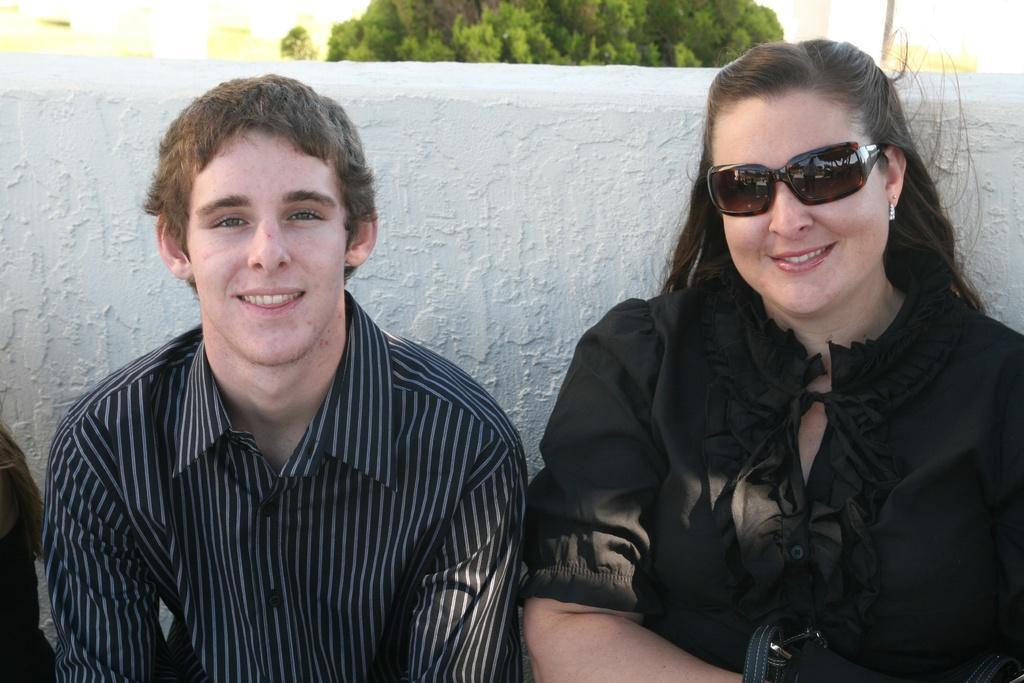In one or two sentences, can you explain what this image depicts? In this image there are two persons, they both are smiling, may be visible in front of the wall, at the top there is a tree. 